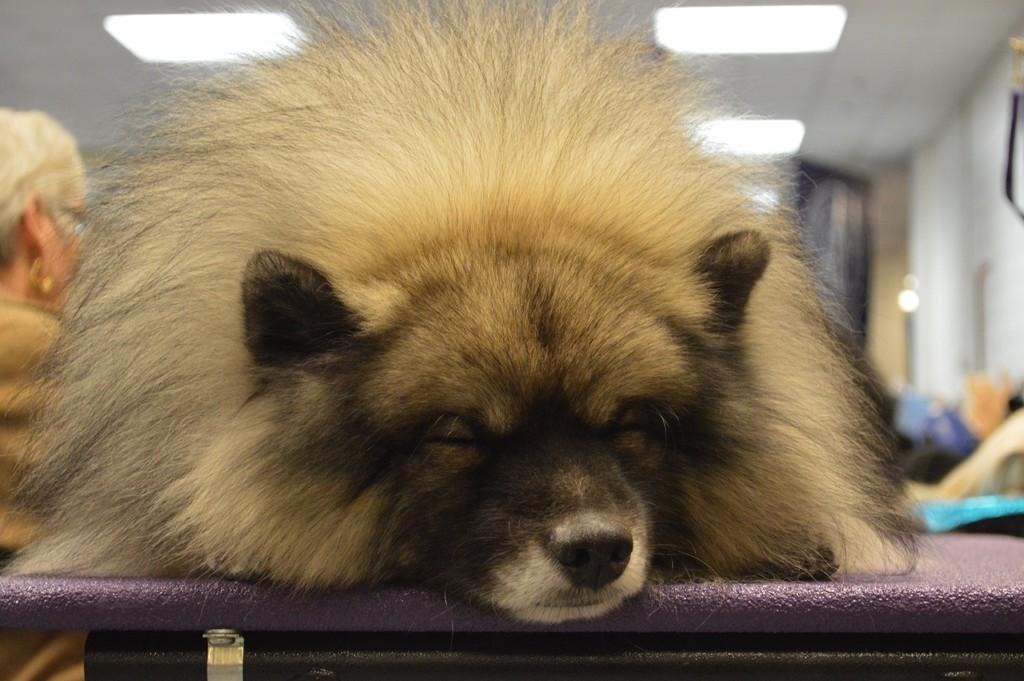What is placed on a surface in the image? There is an animal placed on a surface in the image. Can you describe the person visible in the image? There is a person visible on the backside in the image. What type of structure is depicted in the image? There is a roof in the image, suggesting a building or enclosed space. What type of lighting is present in the image? There are ceiling lights in the image. What title does the person hold in the image? There is no indication of a title or position for the person in the image. How does the earth appear in the image? The image does not depict the earth; it features an animal, a person, a roof, and ceiling lights. 